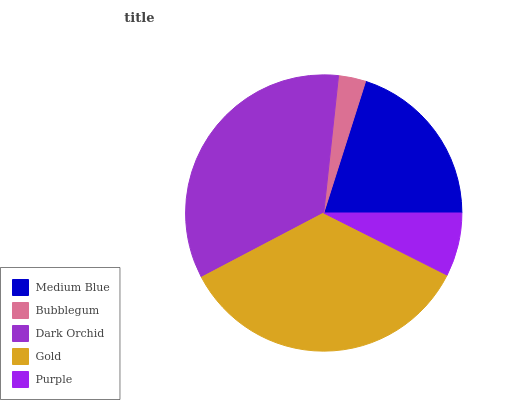Is Bubblegum the minimum?
Answer yes or no. Yes. Is Gold the maximum?
Answer yes or no. Yes. Is Dark Orchid the minimum?
Answer yes or no. No. Is Dark Orchid the maximum?
Answer yes or no. No. Is Dark Orchid greater than Bubblegum?
Answer yes or no. Yes. Is Bubblegum less than Dark Orchid?
Answer yes or no. Yes. Is Bubblegum greater than Dark Orchid?
Answer yes or no. No. Is Dark Orchid less than Bubblegum?
Answer yes or no. No. Is Medium Blue the high median?
Answer yes or no. Yes. Is Medium Blue the low median?
Answer yes or no. Yes. Is Dark Orchid the high median?
Answer yes or no. No. Is Bubblegum the low median?
Answer yes or no. No. 